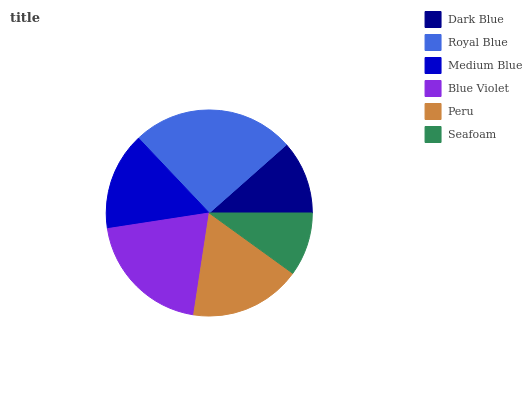Is Seafoam the minimum?
Answer yes or no. Yes. Is Royal Blue the maximum?
Answer yes or no. Yes. Is Medium Blue the minimum?
Answer yes or no. No. Is Medium Blue the maximum?
Answer yes or no. No. Is Royal Blue greater than Medium Blue?
Answer yes or no. Yes. Is Medium Blue less than Royal Blue?
Answer yes or no. Yes. Is Medium Blue greater than Royal Blue?
Answer yes or no. No. Is Royal Blue less than Medium Blue?
Answer yes or no. No. Is Peru the high median?
Answer yes or no. Yes. Is Medium Blue the low median?
Answer yes or no. Yes. Is Dark Blue the high median?
Answer yes or no. No. Is Blue Violet the low median?
Answer yes or no. No. 